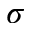<formula> <loc_0><loc_0><loc_500><loc_500>\sigma</formula> 